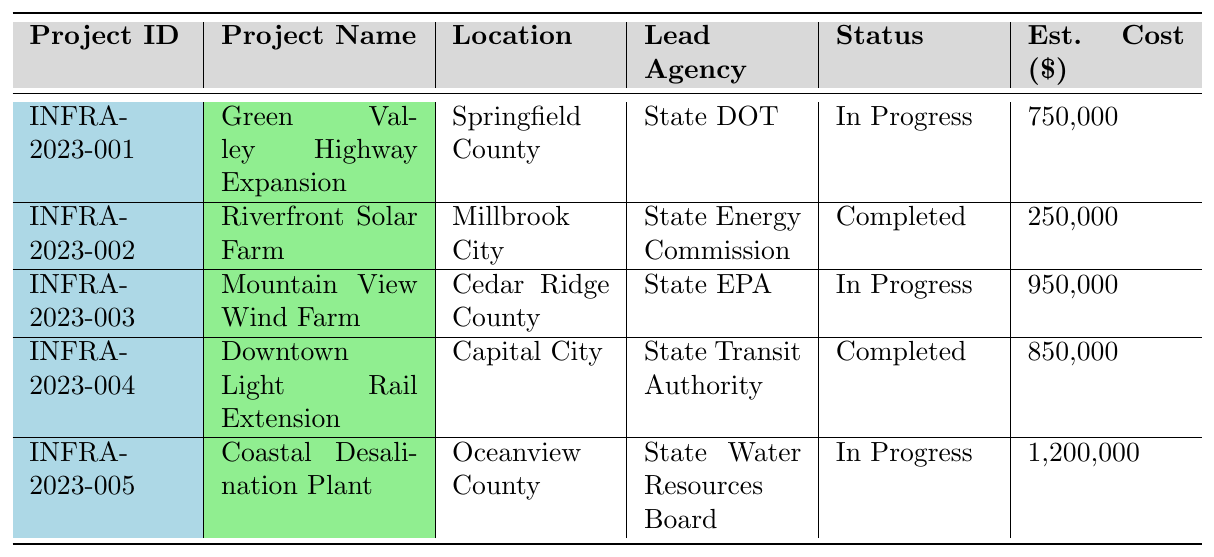What is the estimated cost of the Mountain View Wind Farm project? The estimated cost of the Mountain View Wind Farm project is listed in the table under the "Est. Cost ($)" column next to its name. It shows a value of 950,000.
Answer: 950,000 How many projects are currently in progress? The status of each project is shown in the "Status" column. By counting the entries marked as "In Progress" (Green Valley Highway Expansion, Mountain View Wind Farm, Coastal Desalination Plant), we find there are three projects.
Answer: 3 Which project has the lowest estimated cost? The estimated costs for all projects are provided in the "Est. Cost ($)" column. The lowest cost is associated with the Riverfront Solar Farm project, at 250,000.
Answer: 250,000 Is the Downtown Light Rail Extension project completed? The status for the Downtown Light Rail Extension project is provided in the "Status" column. It shows "Completed," which confirms that the project is indeed finished.
Answer: Yes What are the key findings of the Green Valley Highway Expansion project? The key findings for each project are listed in the table. For the Green Valley Highway Expansion project, it states: "Potential impact on local wetlands; noise pollution concerns."
Answer: Potential impact on local wetlands; noise pollution concerns What is the total estimated cost of all projects listed? To find the total estimated cost, sum the values from the "Est. Cost ($)" column: 750,000 + 250,000 + 950,000 + 850,000 + 1,200,000 = 3,000,000.
Answer: 3,000,000 Which agency leads the Riverfront Solar Farm project? The lead agency for the Riverfront Solar Farm project is indicated in the "Lead Agency" column. It is the "State Energy Commission."
Answer: State Energy Commission Is there a project with a positive impact on air quality? Reviewing the key findings, the Downtown Light Rail Extension project mentions a "Positive impact on air quality," confirming the existence of such a project.
Answer: Yes What is the duration of the Coastal Desalination Plant project? The duration can be calculated by subtracting the start date (July 1, 2023) from the completion date (March 31, 2024). This gives a total duration of approximately 9 months.
Answer: Approximately 9 months How many projects are located in Capital City? The location column shows that only the Downtown Light Rail Extension project is listed under Capital City, indicating it is the sole project in that location.
Answer: 1 What concerns are associated with the Coastal Desalination Plant project? The key findings for the Coastal Desalination Plant project mention "Concerns about marine ecosystem; improved water security for the region," indicating environmental considerations.
Answer: Concerns about marine ecosystem; improved water security for the region 